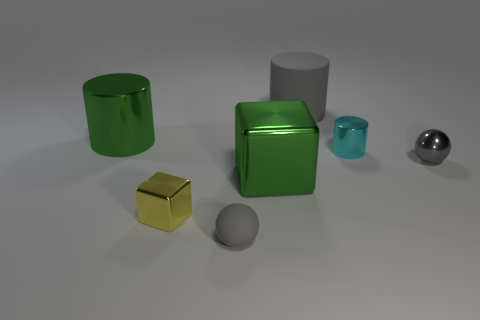Subtract all yellow cylinders. Subtract all yellow balls. How many cylinders are left? 3 Add 2 yellow cubes. How many objects exist? 9 Subtract all cylinders. How many objects are left? 4 Add 7 gray balls. How many gray balls exist? 9 Subtract 0 cyan balls. How many objects are left? 7 Subtract all small brown metallic things. Subtract all big green cylinders. How many objects are left? 6 Add 6 small gray rubber spheres. How many small gray rubber spheres are left? 7 